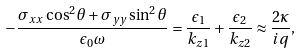Convert formula to latex. <formula><loc_0><loc_0><loc_500><loc_500>- \frac { { \sigma } _ { x x } \cos ^ { 2 } \theta + { \sigma } _ { y y } \sin ^ { 2 } \theta } { { \epsilon } _ { 0 } \omega } = \frac { { \epsilon } _ { 1 } } { { k } _ { z 1 } } + \frac { { \epsilon } _ { 2 } } { { k } _ { z 2 } } \approx \frac { 2 \kappa } { i q } ,</formula> 